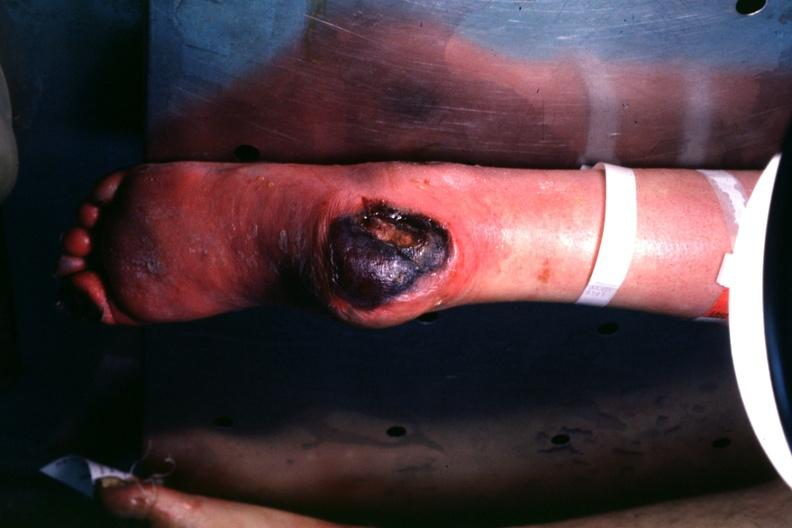what does this image show?
Answer the question using a single word or phrase. Good example of diabetic lesion va. 